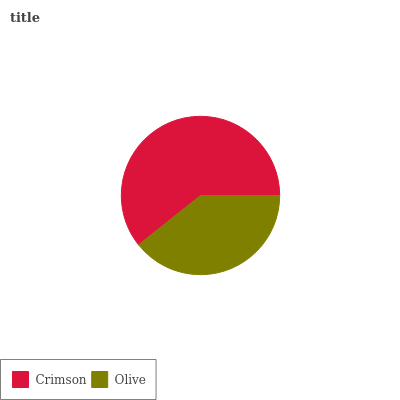Is Olive the minimum?
Answer yes or no. Yes. Is Crimson the maximum?
Answer yes or no. Yes. Is Olive the maximum?
Answer yes or no. No. Is Crimson greater than Olive?
Answer yes or no. Yes. Is Olive less than Crimson?
Answer yes or no. Yes. Is Olive greater than Crimson?
Answer yes or no. No. Is Crimson less than Olive?
Answer yes or no. No. Is Crimson the high median?
Answer yes or no. Yes. Is Olive the low median?
Answer yes or no. Yes. Is Olive the high median?
Answer yes or no. No. Is Crimson the low median?
Answer yes or no. No. 